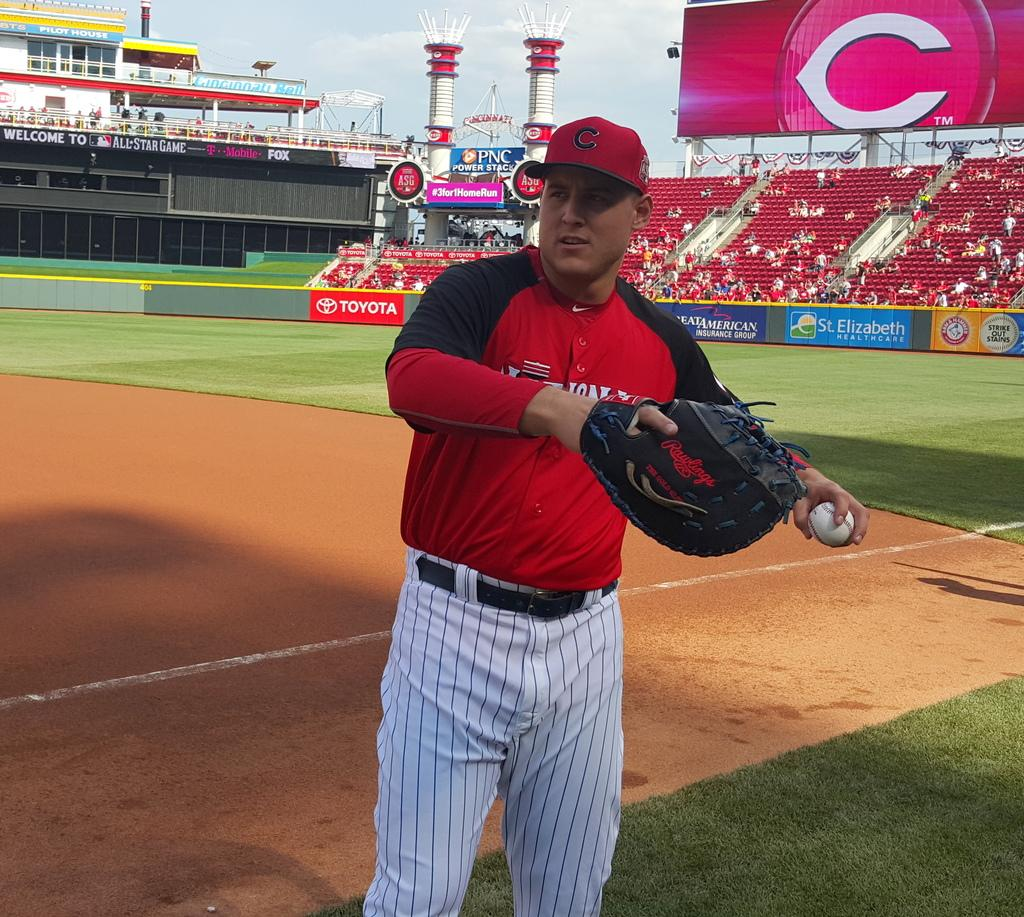<image>
Share a concise interpretation of the image provided. A player with a C on his stands in front of a large billboard that also displays a C 